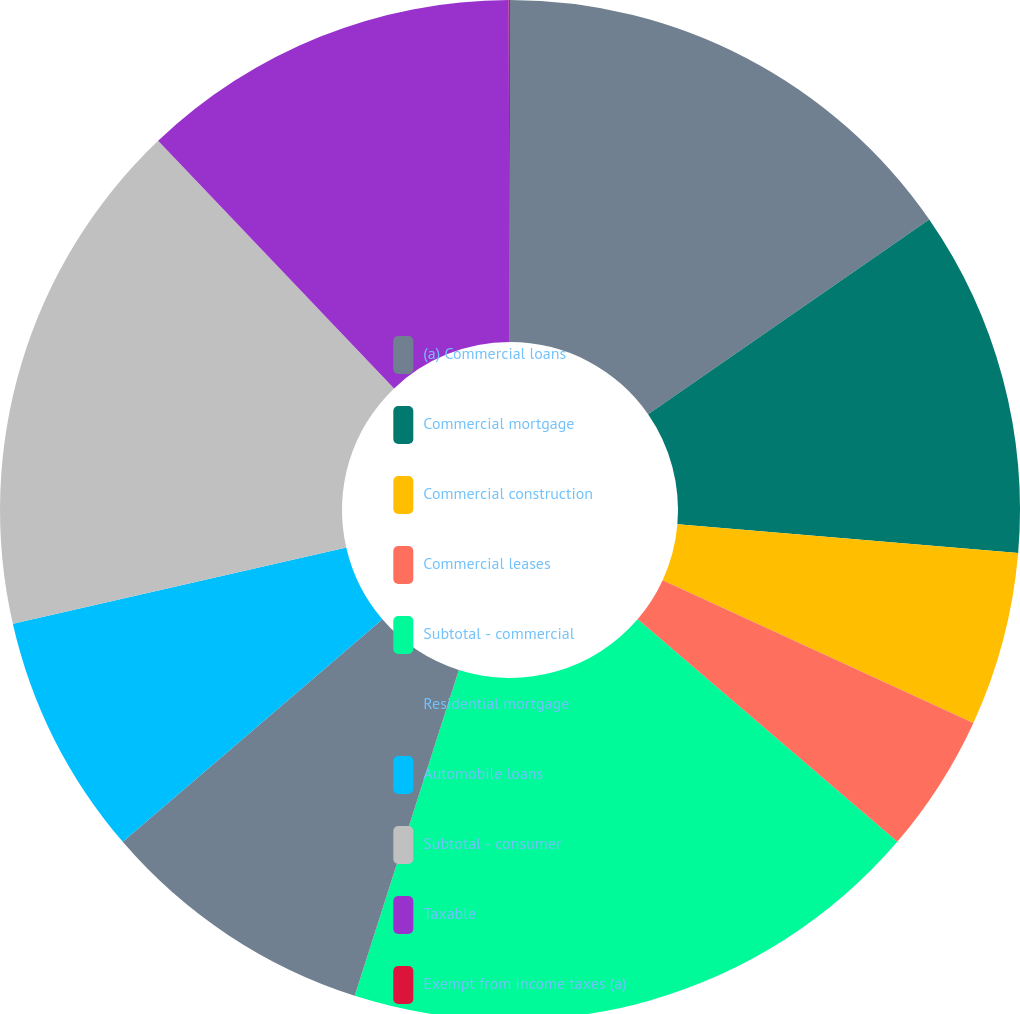Convert chart. <chart><loc_0><loc_0><loc_500><loc_500><pie_chart><fcel>(a) Commercial loans<fcel>Commercial mortgage<fcel>Commercial construction<fcel>Commercial leases<fcel>Subtotal - commercial<fcel>Residential mortgage<fcel>Automobile loans<fcel>Subtotal - consumer<fcel>Taxable<fcel>Exempt from income taxes (a)<nl><fcel>15.36%<fcel>10.99%<fcel>5.51%<fcel>4.42%<fcel>18.65%<fcel>8.8%<fcel>7.7%<fcel>16.46%<fcel>12.08%<fcel>0.04%<nl></chart> 